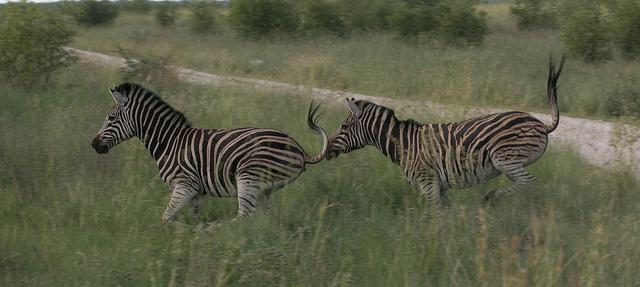Are these two zebra playing in the field?
Quick response, please. Yes. Are the animals moving in the same direction?
Be succinct. Yes. Is this animal running?
Be succinct. Yes. Is it night time?
Write a very short answer. No. Are these zebras in motion?
Short answer required. Yes. 